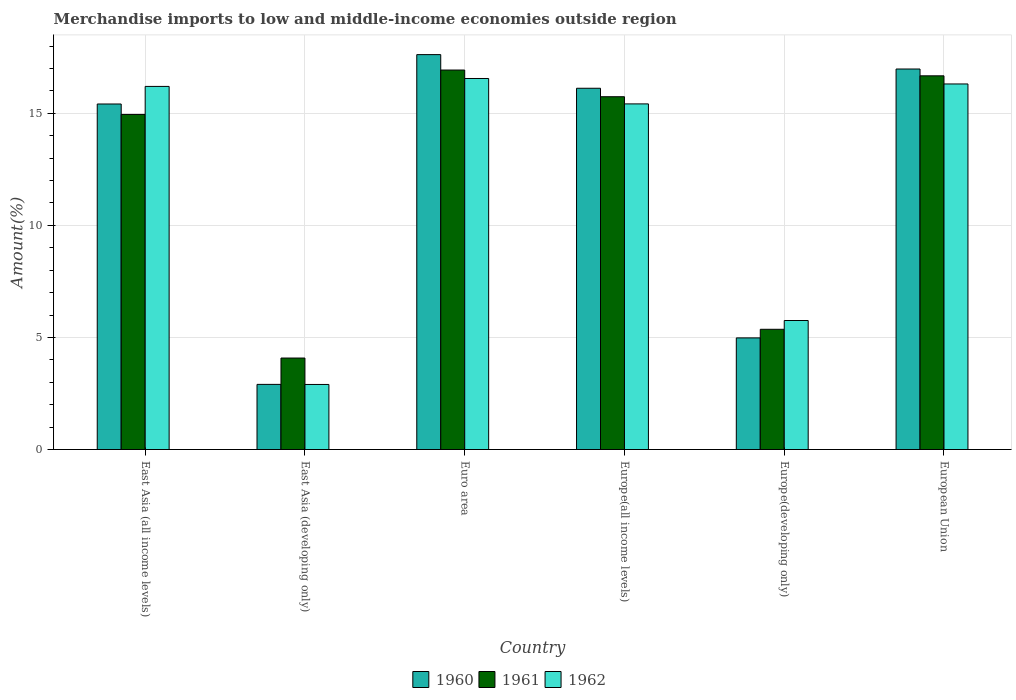Are the number of bars on each tick of the X-axis equal?
Provide a short and direct response. Yes. How many bars are there on the 6th tick from the right?
Make the answer very short. 3. What is the label of the 2nd group of bars from the left?
Your answer should be compact. East Asia (developing only). What is the percentage of amount earned from merchandise imports in 1962 in European Union?
Your answer should be very brief. 16.31. Across all countries, what is the maximum percentage of amount earned from merchandise imports in 1960?
Ensure brevity in your answer.  17.62. Across all countries, what is the minimum percentage of amount earned from merchandise imports in 1962?
Ensure brevity in your answer.  2.9. In which country was the percentage of amount earned from merchandise imports in 1962 minimum?
Give a very brief answer. East Asia (developing only). What is the total percentage of amount earned from merchandise imports in 1960 in the graph?
Your answer should be compact. 74.01. What is the difference between the percentage of amount earned from merchandise imports in 1961 in East Asia (developing only) and that in Europe(developing only)?
Your answer should be compact. -1.28. What is the difference between the percentage of amount earned from merchandise imports in 1961 in East Asia (all income levels) and the percentage of amount earned from merchandise imports in 1960 in Europe(all income levels)?
Provide a succinct answer. -1.17. What is the average percentage of amount earned from merchandise imports in 1960 per country?
Keep it short and to the point. 12.33. What is the difference between the percentage of amount earned from merchandise imports of/in 1960 and percentage of amount earned from merchandise imports of/in 1962 in European Union?
Your answer should be compact. 0.67. In how many countries, is the percentage of amount earned from merchandise imports in 1962 greater than 11 %?
Ensure brevity in your answer.  4. What is the ratio of the percentage of amount earned from merchandise imports in 1962 in Europe(all income levels) to that in Europe(developing only)?
Offer a terse response. 2.68. Is the percentage of amount earned from merchandise imports in 1960 in East Asia (all income levels) less than that in Europe(developing only)?
Ensure brevity in your answer.  No. What is the difference between the highest and the second highest percentage of amount earned from merchandise imports in 1960?
Ensure brevity in your answer.  -0.64. What is the difference between the highest and the lowest percentage of amount earned from merchandise imports in 1962?
Your answer should be very brief. 13.65. What does the 2nd bar from the left in Europe(all income levels) represents?
Give a very brief answer. 1961. What does the 3rd bar from the right in Europe(developing only) represents?
Your answer should be compact. 1960. Is it the case that in every country, the sum of the percentage of amount earned from merchandise imports in 1960 and percentage of amount earned from merchandise imports in 1961 is greater than the percentage of amount earned from merchandise imports in 1962?
Your answer should be very brief. Yes. How many bars are there?
Your answer should be very brief. 18. Are all the bars in the graph horizontal?
Your answer should be compact. No. Are the values on the major ticks of Y-axis written in scientific E-notation?
Offer a terse response. No. Where does the legend appear in the graph?
Offer a terse response. Bottom center. What is the title of the graph?
Ensure brevity in your answer.  Merchandise imports to low and middle-income economies outside region. What is the label or title of the X-axis?
Make the answer very short. Country. What is the label or title of the Y-axis?
Give a very brief answer. Amount(%). What is the Amount(%) in 1960 in East Asia (all income levels)?
Ensure brevity in your answer.  15.41. What is the Amount(%) in 1961 in East Asia (all income levels)?
Provide a short and direct response. 14.95. What is the Amount(%) of 1962 in East Asia (all income levels)?
Offer a very short reply. 16.2. What is the Amount(%) of 1960 in East Asia (developing only)?
Your response must be concise. 2.91. What is the Amount(%) of 1961 in East Asia (developing only)?
Your answer should be very brief. 4.08. What is the Amount(%) of 1962 in East Asia (developing only)?
Your answer should be compact. 2.9. What is the Amount(%) of 1960 in Euro area?
Your answer should be very brief. 17.62. What is the Amount(%) in 1961 in Euro area?
Offer a terse response. 16.93. What is the Amount(%) of 1962 in Euro area?
Your answer should be very brief. 16.55. What is the Amount(%) of 1960 in Europe(all income levels)?
Give a very brief answer. 16.12. What is the Amount(%) in 1961 in Europe(all income levels)?
Ensure brevity in your answer.  15.74. What is the Amount(%) of 1962 in Europe(all income levels)?
Offer a very short reply. 15.42. What is the Amount(%) in 1960 in Europe(developing only)?
Give a very brief answer. 4.98. What is the Amount(%) of 1961 in Europe(developing only)?
Provide a succinct answer. 5.36. What is the Amount(%) in 1962 in Europe(developing only)?
Make the answer very short. 5.76. What is the Amount(%) of 1960 in European Union?
Offer a very short reply. 16.98. What is the Amount(%) of 1961 in European Union?
Your answer should be very brief. 16.67. What is the Amount(%) in 1962 in European Union?
Your answer should be very brief. 16.31. Across all countries, what is the maximum Amount(%) in 1960?
Offer a terse response. 17.62. Across all countries, what is the maximum Amount(%) in 1961?
Make the answer very short. 16.93. Across all countries, what is the maximum Amount(%) of 1962?
Your answer should be compact. 16.55. Across all countries, what is the minimum Amount(%) of 1960?
Give a very brief answer. 2.91. Across all countries, what is the minimum Amount(%) in 1961?
Your answer should be compact. 4.08. Across all countries, what is the minimum Amount(%) in 1962?
Offer a terse response. 2.9. What is the total Amount(%) in 1960 in the graph?
Provide a succinct answer. 74.01. What is the total Amount(%) in 1961 in the graph?
Your answer should be very brief. 73.73. What is the total Amount(%) of 1962 in the graph?
Offer a very short reply. 73.14. What is the difference between the Amount(%) in 1960 in East Asia (all income levels) and that in East Asia (developing only)?
Your answer should be very brief. 12.51. What is the difference between the Amount(%) in 1961 in East Asia (all income levels) and that in East Asia (developing only)?
Keep it short and to the point. 10.87. What is the difference between the Amount(%) of 1962 in East Asia (all income levels) and that in East Asia (developing only)?
Keep it short and to the point. 13.3. What is the difference between the Amount(%) in 1960 in East Asia (all income levels) and that in Euro area?
Your answer should be very brief. -2.2. What is the difference between the Amount(%) of 1961 in East Asia (all income levels) and that in Euro area?
Offer a very short reply. -1.98. What is the difference between the Amount(%) of 1962 in East Asia (all income levels) and that in Euro area?
Give a very brief answer. -0.35. What is the difference between the Amount(%) of 1960 in East Asia (all income levels) and that in Europe(all income levels)?
Your response must be concise. -0.7. What is the difference between the Amount(%) in 1961 in East Asia (all income levels) and that in Europe(all income levels)?
Offer a terse response. -0.79. What is the difference between the Amount(%) of 1962 in East Asia (all income levels) and that in Europe(all income levels)?
Your answer should be very brief. 0.78. What is the difference between the Amount(%) of 1960 in East Asia (all income levels) and that in Europe(developing only)?
Make the answer very short. 10.43. What is the difference between the Amount(%) of 1961 in East Asia (all income levels) and that in Europe(developing only)?
Give a very brief answer. 9.58. What is the difference between the Amount(%) of 1962 in East Asia (all income levels) and that in Europe(developing only)?
Make the answer very short. 10.44. What is the difference between the Amount(%) in 1960 in East Asia (all income levels) and that in European Union?
Provide a short and direct response. -1.56. What is the difference between the Amount(%) of 1961 in East Asia (all income levels) and that in European Union?
Your answer should be very brief. -1.72. What is the difference between the Amount(%) in 1962 in East Asia (all income levels) and that in European Union?
Your answer should be very brief. -0.11. What is the difference between the Amount(%) in 1960 in East Asia (developing only) and that in Euro area?
Give a very brief answer. -14.71. What is the difference between the Amount(%) of 1961 in East Asia (developing only) and that in Euro area?
Your answer should be compact. -12.85. What is the difference between the Amount(%) of 1962 in East Asia (developing only) and that in Euro area?
Your answer should be very brief. -13.65. What is the difference between the Amount(%) in 1960 in East Asia (developing only) and that in Europe(all income levels)?
Give a very brief answer. -13.21. What is the difference between the Amount(%) in 1961 in East Asia (developing only) and that in Europe(all income levels)?
Your response must be concise. -11.66. What is the difference between the Amount(%) of 1962 in East Asia (developing only) and that in Europe(all income levels)?
Offer a terse response. -12.52. What is the difference between the Amount(%) of 1960 in East Asia (developing only) and that in Europe(developing only)?
Keep it short and to the point. -2.07. What is the difference between the Amount(%) of 1961 in East Asia (developing only) and that in Europe(developing only)?
Your response must be concise. -1.28. What is the difference between the Amount(%) in 1962 in East Asia (developing only) and that in Europe(developing only)?
Provide a succinct answer. -2.85. What is the difference between the Amount(%) in 1960 in East Asia (developing only) and that in European Union?
Your response must be concise. -14.07. What is the difference between the Amount(%) of 1961 in East Asia (developing only) and that in European Union?
Offer a terse response. -12.59. What is the difference between the Amount(%) in 1962 in East Asia (developing only) and that in European Union?
Provide a succinct answer. -13.41. What is the difference between the Amount(%) of 1960 in Euro area and that in Europe(all income levels)?
Keep it short and to the point. 1.5. What is the difference between the Amount(%) of 1961 in Euro area and that in Europe(all income levels)?
Your answer should be very brief. 1.19. What is the difference between the Amount(%) in 1962 in Euro area and that in Europe(all income levels)?
Provide a short and direct response. 1.13. What is the difference between the Amount(%) in 1960 in Euro area and that in Europe(developing only)?
Give a very brief answer. 12.64. What is the difference between the Amount(%) in 1961 in Euro area and that in Europe(developing only)?
Give a very brief answer. 11.57. What is the difference between the Amount(%) in 1962 in Euro area and that in Europe(developing only)?
Provide a short and direct response. 10.8. What is the difference between the Amount(%) in 1960 in Euro area and that in European Union?
Keep it short and to the point. 0.64. What is the difference between the Amount(%) in 1961 in Euro area and that in European Union?
Give a very brief answer. 0.26. What is the difference between the Amount(%) of 1962 in Euro area and that in European Union?
Provide a short and direct response. 0.24. What is the difference between the Amount(%) in 1960 in Europe(all income levels) and that in Europe(developing only)?
Your answer should be very brief. 11.14. What is the difference between the Amount(%) in 1961 in Europe(all income levels) and that in Europe(developing only)?
Keep it short and to the point. 10.38. What is the difference between the Amount(%) of 1962 in Europe(all income levels) and that in Europe(developing only)?
Offer a terse response. 9.66. What is the difference between the Amount(%) of 1960 in Europe(all income levels) and that in European Union?
Keep it short and to the point. -0.86. What is the difference between the Amount(%) of 1961 in Europe(all income levels) and that in European Union?
Provide a short and direct response. -0.93. What is the difference between the Amount(%) of 1962 in Europe(all income levels) and that in European Union?
Your answer should be compact. -0.89. What is the difference between the Amount(%) of 1960 in Europe(developing only) and that in European Union?
Ensure brevity in your answer.  -12. What is the difference between the Amount(%) in 1961 in Europe(developing only) and that in European Union?
Provide a short and direct response. -11.31. What is the difference between the Amount(%) in 1962 in Europe(developing only) and that in European Union?
Offer a terse response. -10.55. What is the difference between the Amount(%) in 1960 in East Asia (all income levels) and the Amount(%) in 1961 in East Asia (developing only)?
Your answer should be compact. 11.33. What is the difference between the Amount(%) of 1960 in East Asia (all income levels) and the Amount(%) of 1962 in East Asia (developing only)?
Provide a short and direct response. 12.51. What is the difference between the Amount(%) in 1961 in East Asia (all income levels) and the Amount(%) in 1962 in East Asia (developing only)?
Offer a very short reply. 12.05. What is the difference between the Amount(%) in 1960 in East Asia (all income levels) and the Amount(%) in 1961 in Euro area?
Your response must be concise. -1.51. What is the difference between the Amount(%) of 1960 in East Asia (all income levels) and the Amount(%) of 1962 in Euro area?
Provide a short and direct response. -1.14. What is the difference between the Amount(%) in 1961 in East Asia (all income levels) and the Amount(%) in 1962 in Euro area?
Offer a very short reply. -1.6. What is the difference between the Amount(%) of 1960 in East Asia (all income levels) and the Amount(%) of 1961 in Europe(all income levels)?
Offer a terse response. -0.32. What is the difference between the Amount(%) in 1960 in East Asia (all income levels) and the Amount(%) in 1962 in Europe(all income levels)?
Ensure brevity in your answer.  -0. What is the difference between the Amount(%) in 1961 in East Asia (all income levels) and the Amount(%) in 1962 in Europe(all income levels)?
Your response must be concise. -0.47. What is the difference between the Amount(%) of 1960 in East Asia (all income levels) and the Amount(%) of 1961 in Europe(developing only)?
Provide a short and direct response. 10.05. What is the difference between the Amount(%) in 1960 in East Asia (all income levels) and the Amount(%) in 1962 in Europe(developing only)?
Give a very brief answer. 9.66. What is the difference between the Amount(%) of 1961 in East Asia (all income levels) and the Amount(%) of 1962 in Europe(developing only)?
Your response must be concise. 9.19. What is the difference between the Amount(%) of 1960 in East Asia (all income levels) and the Amount(%) of 1961 in European Union?
Provide a succinct answer. -1.26. What is the difference between the Amount(%) of 1960 in East Asia (all income levels) and the Amount(%) of 1962 in European Union?
Offer a very short reply. -0.89. What is the difference between the Amount(%) of 1961 in East Asia (all income levels) and the Amount(%) of 1962 in European Union?
Your response must be concise. -1.36. What is the difference between the Amount(%) in 1960 in East Asia (developing only) and the Amount(%) in 1961 in Euro area?
Your answer should be very brief. -14.02. What is the difference between the Amount(%) in 1960 in East Asia (developing only) and the Amount(%) in 1962 in Euro area?
Ensure brevity in your answer.  -13.65. What is the difference between the Amount(%) of 1961 in East Asia (developing only) and the Amount(%) of 1962 in Euro area?
Offer a terse response. -12.47. What is the difference between the Amount(%) of 1960 in East Asia (developing only) and the Amount(%) of 1961 in Europe(all income levels)?
Provide a succinct answer. -12.83. What is the difference between the Amount(%) of 1960 in East Asia (developing only) and the Amount(%) of 1962 in Europe(all income levels)?
Give a very brief answer. -12.51. What is the difference between the Amount(%) in 1961 in East Asia (developing only) and the Amount(%) in 1962 in Europe(all income levels)?
Your response must be concise. -11.34. What is the difference between the Amount(%) in 1960 in East Asia (developing only) and the Amount(%) in 1961 in Europe(developing only)?
Your answer should be compact. -2.46. What is the difference between the Amount(%) in 1960 in East Asia (developing only) and the Amount(%) in 1962 in Europe(developing only)?
Offer a terse response. -2.85. What is the difference between the Amount(%) in 1961 in East Asia (developing only) and the Amount(%) in 1962 in Europe(developing only)?
Your response must be concise. -1.67. What is the difference between the Amount(%) of 1960 in East Asia (developing only) and the Amount(%) of 1961 in European Union?
Your answer should be compact. -13.77. What is the difference between the Amount(%) in 1960 in East Asia (developing only) and the Amount(%) in 1962 in European Union?
Give a very brief answer. -13.4. What is the difference between the Amount(%) in 1961 in East Asia (developing only) and the Amount(%) in 1962 in European Union?
Offer a very short reply. -12.23. What is the difference between the Amount(%) in 1960 in Euro area and the Amount(%) in 1961 in Europe(all income levels)?
Your answer should be compact. 1.88. What is the difference between the Amount(%) of 1960 in Euro area and the Amount(%) of 1962 in Europe(all income levels)?
Your answer should be compact. 2.2. What is the difference between the Amount(%) in 1961 in Euro area and the Amount(%) in 1962 in Europe(all income levels)?
Make the answer very short. 1.51. What is the difference between the Amount(%) of 1960 in Euro area and the Amount(%) of 1961 in Europe(developing only)?
Offer a very short reply. 12.25. What is the difference between the Amount(%) in 1960 in Euro area and the Amount(%) in 1962 in Europe(developing only)?
Your answer should be compact. 11.86. What is the difference between the Amount(%) in 1961 in Euro area and the Amount(%) in 1962 in Europe(developing only)?
Your answer should be very brief. 11.17. What is the difference between the Amount(%) of 1960 in Euro area and the Amount(%) of 1961 in European Union?
Provide a short and direct response. 0.95. What is the difference between the Amount(%) of 1960 in Euro area and the Amount(%) of 1962 in European Union?
Offer a terse response. 1.31. What is the difference between the Amount(%) in 1961 in Euro area and the Amount(%) in 1962 in European Union?
Make the answer very short. 0.62. What is the difference between the Amount(%) in 1960 in Europe(all income levels) and the Amount(%) in 1961 in Europe(developing only)?
Your answer should be compact. 10.75. What is the difference between the Amount(%) of 1960 in Europe(all income levels) and the Amount(%) of 1962 in Europe(developing only)?
Give a very brief answer. 10.36. What is the difference between the Amount(%) in 1961 in Europe(all income levels) and the Amount(%) in 1962 in Europe(developing only)?
Offer a very short reply. 9.98. What is the difference between the Amount(%) of 1960 in Europe(all income levels) and the Amount(%) of 1961 in European Union?
Your answer should be very brief. -0.55. What is the difference between the Amount(%) of 1960 in Europe(all income levels) and the Amount(%) of 1962 in European Union?
Ensure brevity in your answer.  -0.19. What is the difference between the Amount(%) of 1961 in Europe(all income levels) and the Amount(%) of 1962 in European Union?
Offer a very short reply. -0.57. What is the difference between the Amount(%) in 1960 in Europe(developing only) and the Amount(%) in 1961 in European Union?
Ensure brevity in your answer.  -11.69. What is the difference between the Amount(%) in 1960 in Europe(developing only) and the Amount(%) in 1962 in European Union?
Provide a short and direct response. -11.33. What is the difference between the Amount(%) in 1961 in Europe(developing only) and the Amount(%) in 1962 in European Union?
Provide a short and direct response. -10.94. What is the average Amount(%) in 1960 per country?
Offer a very short reply. 12.33. What is the average Amount(%) of 1961 per country?
Your answer should be compact. 12.29. What is the average Amount(%) in 1962 per country?
Offer a very short reply. 12.19. What is the difference between the Amount(%) in 1960 and Amount(%) in 1961 in East Asia (all income levels)?
Provide a succinct answer. 0.47. What is the difference between the Amount(%) of 1960 and Amount(%) of 1962 in East Asia (all income levels)?
Your answer should be very brief. -0.78. What is the difference between the Amount(%) in 1961 and Amount(%) in 1962 in East Asia (all income levels)?
Ensure brevity in your answer.  -1.25. What is the difference between the Amount(%) in 1960 and Amount(%) in 1961 in East Asia (developing only)?
Offer a very short reply. -1.18. What is the difference between the Amount(%) of 1960 and Amount(%) of 1962 in East Asia (developing only)?
Provide a succinct answer. 0. What is the difference between the Amount(%) of 1961 and Amount(%) of 1962 in East Asia (developing only)?
Your answer should be compact. 1.18. What is the difference between the Amount(%) of 1960 and Amount(%) of 1961 in Euro area?
Your answer should be very brief. 0.69. What is the difference between the Amount(%) in 1960 and Amount(%) in 1962 in Euro area?
Ensure brevity in your answer.  1.07. What is the difference between the Amount(%) of 1961 and Amount(%) of 1962 in Euro area?
Provide a short and direct response. 0.38. What is the difference between the Amount(%) of 1960 and Amount(%) of 1961 in Europe(all income levels)?
Keep it short and to the point. 0.38. What is the difference between the Amount(%) in 1960 and Amount(%) in 1962 in Europe(all income levels)?
Provide a short and direct response. 0.7. What is the difference between the Amount(%) of 1961 and Amount(%) of 1962 in Europe(all income levels)?
Make the answer very short. 0.32. What is the difference between the Amount(%) of 1960 and Amount(%) of 1961 in Europe(developing only)?
Ensure brevity in your answer.  -0.38. What is the difference between the Amount(%) of 1960 and Amount(%) of 1962 in Europe(developing only)?
Offer a very short reply. -0.78. What is the difference between the Amount(%) in 1961 and Amount(%) in 1962 in Europe(developing only)?
Provide a succinct answer. -0.39. What is the difference between the Amount(%) of 1960 and Amount(%) of 1961 in European Union?
Make the answer very short. 0.3. What is the difference between the Amount(%) in 1960 and Amount(%) in 1962 in European Union?
Offer a terse response. 0.67. What is the difference between the Amount(%) in 1961 and Amount(%) in 1962 in European Union?
Keep it short and to the point. 0.36. What is the ratio of the Amount(%) in 1960 in East Asia (all income levels) to that in East Asia (developing only)?
Give a very brief answer. 5.3. What is the ratio of the Amount(%) of 1961 in East Asia (all income levels) to that in East Asia (developing only)?
Make the answer very short. 3.66. What is the ratio of the Amount(%) of 1962 in East Asia (all income levels) to that in East Asia (developing only)?
Your answer should be very brief. 5.58. What is the ratio of the Amount(%) in 1960 in East Asia (all income levels) to that in Euro area?
Offer a very short reply. 0.88. What is the ratio of the Amount(%) of 1961 in East Asia (all income levels) to that in Euro area?
Offer a terse response. 0.88. What is the ratio of the Amount(%) of 1962 in East Asia (all income levels) to that in Euro area?
Ensure brevity in your answer.  0.98. What is the ratio of the Amount(%) in 1960 in East Asia (all income levels) to that in Europe(all income levels)?
Your answer should be compact. 0.96. What is the ratio of the Amount(%) in 1961 in East Asia (all income levels) to that in Europe(all income levels)?
Ensure brevity in your answer.  0.95. What is the ratio of the Amount(%) in 1962 in East Asia (all income levels) to that in Europe(all income levels)?
Make the answer very short. 1.05. What is the ratio of the Amount(%) of 1960 in East Asia (all income levels) to that in Europe(developing only)?
Keep it short and to the point. 3.1. What is the ratio of the Amount(%) in 1961 in East Asia (all income levels) to that in Europe(developing only)?
Ensure brevity in your answer.  2.79. What is the ratio of the Amount(%) in 1962 in East Asia (all income levels) to that in Europe(developing only)?
Provide a succinct answer. 2.81. What is the ratio of the Amount(%) of 1960 in East Asia (all income levels) to that in European Union?
Give a very brief answer. 0.91. What is the ratio of the Amount(%) of 1961 in East Asia (all income levels) to that in European Union?
Your answer should be compact. 0.9. What is the ratio of the Amount(%) in 1962 in East Asia (all income levels) to that in European Union?
Give a very brief answer. 0.99. What is the ratio of the Amount(%) in 1960 in East Asia (developing only) to that in Euro area?
Give a very brief answer. 0.16. What is the ratio of the Amount(%) of 1961 in East Asia (developing only) to that in Euro area?
Give a very brief answer. 0.24. What is the ratio of the Amount(%) in 1962 in East Asia (developing only) to that in Euro area?
Your answer should be compact. 0.18. What is the ratio of the Amount(%) of 1960 in East Asia (developing only) to that in Europe(all income levels)?
Your response must be concise. 0.18. What is the ratio of the Amount(%) of 1961 in East Asia (developing only) to that in Europe(all income levels)?
Your response must be concise. 0.26. What is the ratio of the Amount(%) in 1962 in East Asia (developing only) to that in Europe(all income levels)?
Provide a short and direct response. 0.19. What is the ratio of the Amount(%) of 1960 in East Asia (developing only) to that in Europe(developing only)?
Keep it short and to the point. 0.58. What is the ratio of the Amount(%) in 1961 in East Asia (developing only) to that in Europe(developing only)?
Your response must be concise. 0.76. What is the ratio of the Amount(%) of 1962 in East Asia (developing only) to that in Europe(developing only)?
Keep it short and to the point. 0.5. What is the ratio of the Amount(%) in 1960 in East Asia (developing only) to that in European Union?
Offer a terse response. 0.17. What is the ratio of the Amount(%) of 1961 in East Asia (developing only) to that in European Union?
Ensure brevity in your answer.  0.24. What is the ratio of the Amount(%) of 1962 in East Asia (developing only) to that in European Union?
Ensure brevity in your answer.  0.18. What is the ratio of the Amount(%) of 1960 in Euro area to that in Europe(all income levels)?
Keep it short and to the point. 1.09. What is the ratio of the Amount(%) in 1961 in Euro area to that in Europe(all income levels)?
Your answer should be very brief. 1.08. What is the ratio of the Amount(%) in 1962 in Euro area to that in Europe(all income levels)?
Your answer should be very brief. 1.07. What is the ratio of the Amount(%) in 1960 in Euro area to that in Europe(developing only)?
Give a very brief answer. 3.54. What is the ratio of the Amount(%) of 1961 in Euro area to that in Europe(developing only)?
Give a very brief answer. 3.16. What is the ratio of the Amount(%) of 1962 in Euro area to that in Europe(developing only)?
Provide a succinct answer. 2.88. What is the ratio of the Amount(%) in 1960 in Euro area to that in European Union?
Make the answer very short. 1.04. What is the ratio of the Amount(%) of 1961 in Euro area to that in European Union?
Keep it short and to the point. 1.02. What is the ratio of the Amount(%) in 1962 in Euro area to that in European Union?
Offer a terse response. 1.01. What is the ratio of the Amount(%) of 1960 in Europe(all income levels) to that in Europe(developing only)?
Keep it short and to the point. 3.24. What is the ratio of the Amount(%) of 1961 in Europe(all income levels) to that in Europe(developing only)?
Give a very brief answer. 2.93. What is the ratio of the Amount(%) in 1962 in Europe(all income levels) to that in Europe(developing only)?
Give a very brief answer. 2.68. What is the ratio of the Amount(%) in 1960 in Europe(all income levels) to that in European Union?
Offer a terse response. 0.95. What is the ratio of the Amount(%) in 1961 in Europe(all income levels) to that in European Union?
Keep it short and to the point. 0.94. What is the ratio of the Amount(%) of 1962 in Europe(all income levels) to that in European Union?
Offer a very short reply. 0.95. What is the ratio of the Amount(%) of 1960 in Europe(developing only) to that in European Union?
Ensure brevity in your answer.  0.29. What is the ratio of the Amount(%) of 1961 in Europe(developing only) to that in European Union?
Your answer should be compact. 0.32. What is the ratio of the Amount(%) in 1962 in Europe(developing only) to that in European Union?
Keep it short and to the point. 0.35. What is the difference between the highest and the second highest Amount(%) in 1960?
Your response must be concise. 0.64. What is the difference between the highest and the second highest Amount(%) in 1961?
Make the answer very short. 0.26. What is the difference between the highest and the second highest Amount(%) in 1962?
Your answer should be very brief. 0.24. What is the difference between the highest and the lowest Amount(%) in 1960?
Provide a succinct answer. 14.71. What is the difference between the highest and the lowest Amount(%) of 1961?
Make the answer very short. 12.85. What is the difference between the highest and the lowest Amount(%) of 1962?
Offer a terse response. 13.65. 